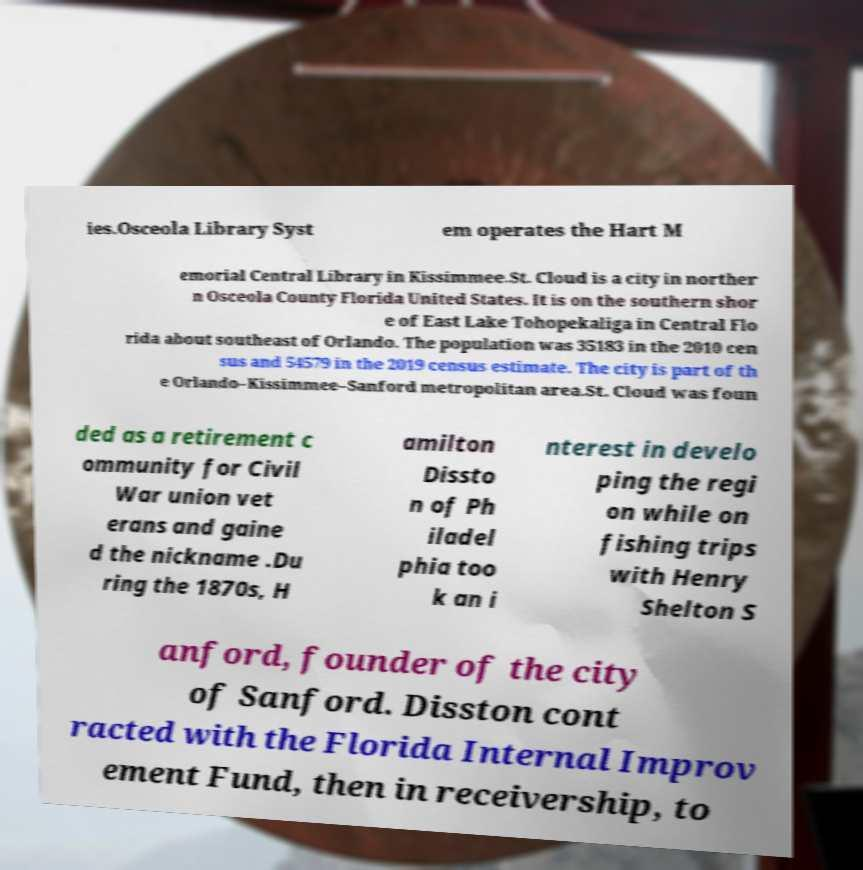Please identify and transcribe the text found in this image. ies.Osceola Library Syst em operates the Hart M emorial Central Library in Kissimmee.St. Cloud is a city in norther n Osceola County Florida United States. It is on the southern shor e of East Lake Tohopekaliga in Central Flo rida about southeast of Orlando. The population was 35183 in the 2010 cen sus and 54579 in the 2019 census estimate. The city is part of th e Orlando–Kissimmee–Sanford metropolitan area.St. Cloud was foun ded as a retirement c ommunity for Civil War union vet erans and gaine d the nickname .Du ring the 1870s, H amilton Dissto n of Ph iladel phia too k an i nterest in develo ping the regi on while on fishing trips with Henry Shelton S anford, founder of the city of Sanford. Disston cont racted with the Florida Internal Improv ement Fund, then in receivership, to 